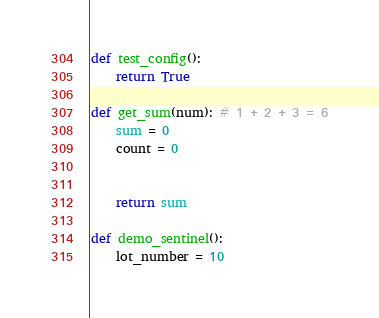<code> <loc_0><loc_0><loc_500><loc_500><_Python_>def test_config():
    return True

def get_sum(num): # 1 + 2 + 3 = 6
    sum = 0
    count = 0


    return sum

def demo_sentinel():
    lot_number = 10
</code> 